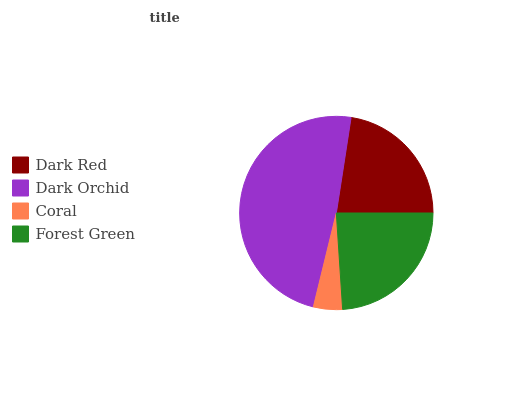Is Coral the minimum?
Answer yes or no. Yes. Is Dark Orchid the maximum?
Answer yes or no. Yes. Is Dark Orchid the minimum?
Answer yes or no. No. Is Coral the maximum?
Answer yes or no. No. Is Dark Orchid greater than Coral?
Answer yes or no. Yes. Is Coral less than Dark Orchid?
Answer yes or no. Yes. Is Coral greater than Dark Orchid?
Answer yes or no. No. Is Dark Orchid less than Coral?
Answer yes or no. No. Is Forest Green the high median?
Answer yes or no. Yes. Is Dark Red the low median?
Answer yes or no. Yes. Is Coral the high median?
Answer yes or no. No. Is Dark Orchid the low median?
Answer yes or no. No. 